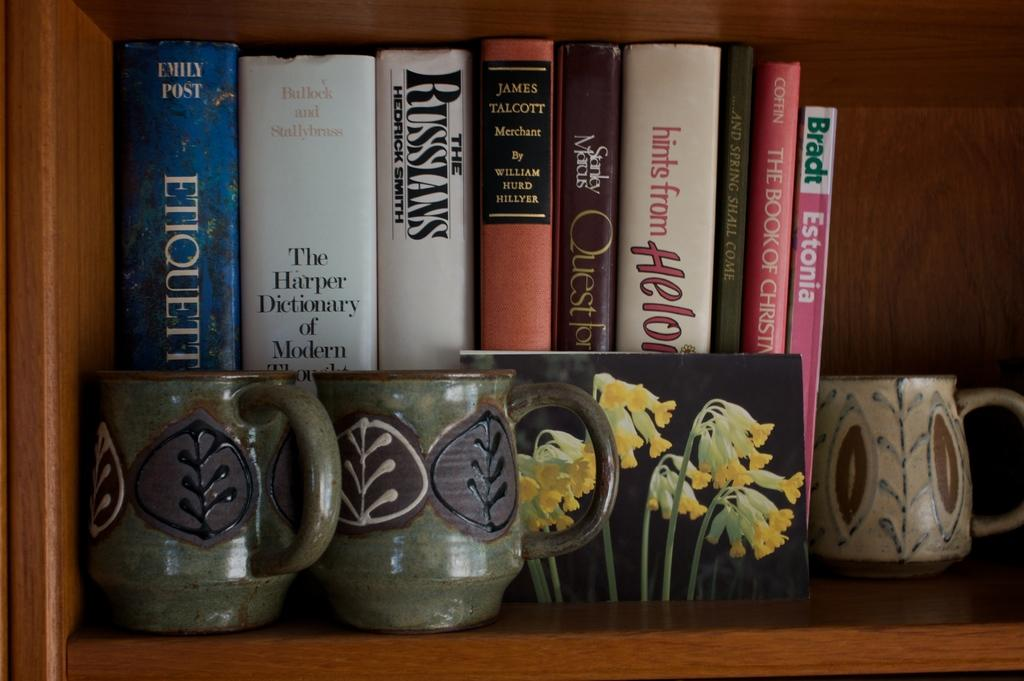Provide a one-sentence caption for the provided image. a book that says the Russians on it. 